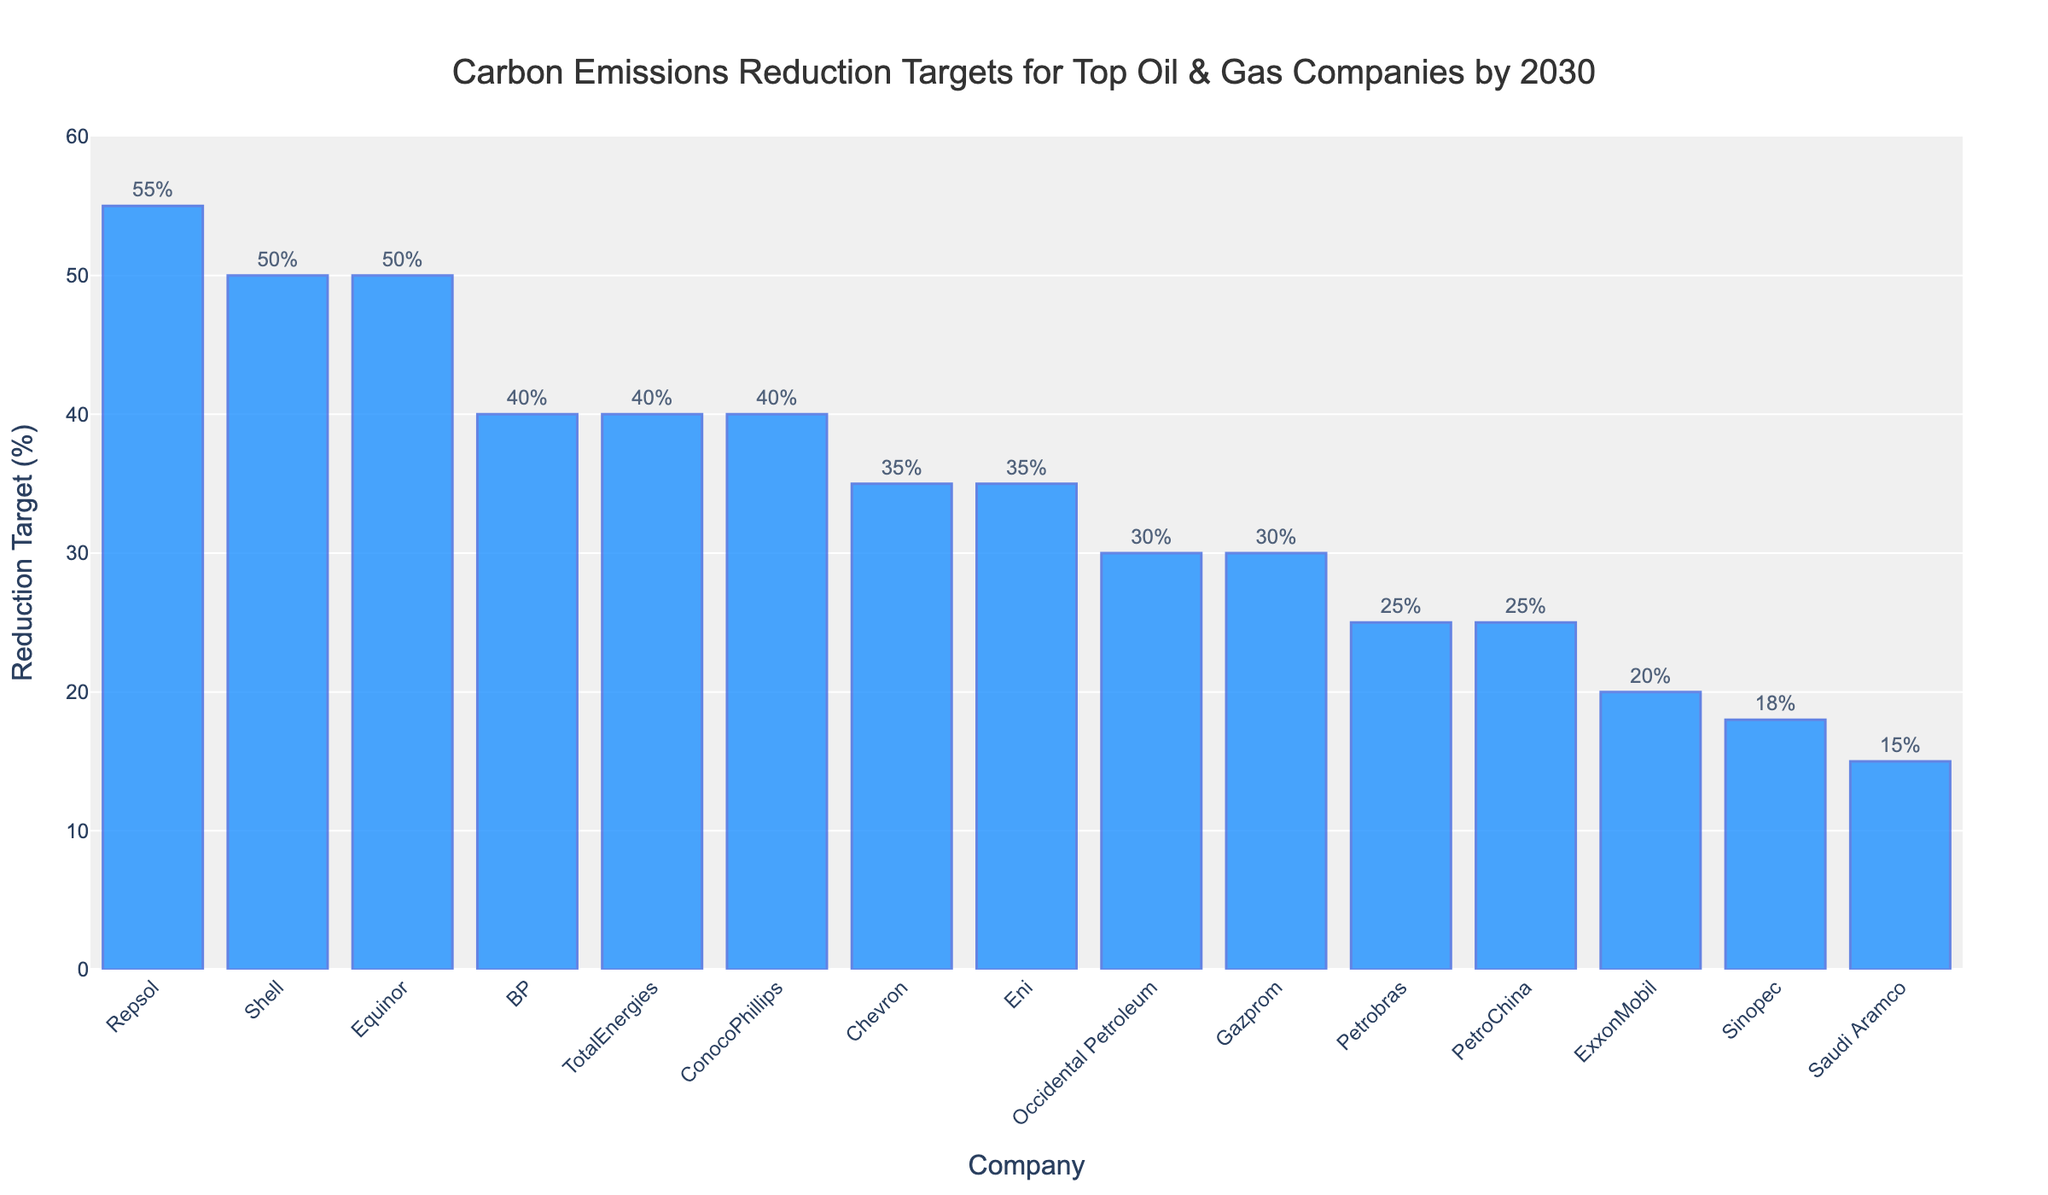Which company has the highest carbon emissions reduction target? Repsol has the highest carbon emissions reduction target of 55%. This is seen by identifying the tallest bar in the chart, which belongs to Repsol.
Answer: Repsol Which companies have a reduction target of 40% by 2030? BP, TotalEnergies, and ConocoPhillips each have a reduction target of 40% by 2030. By checking the heights of the bars and matching them to the 40% mark, these companies stand out.
Answer: BP, TotalEnergies, ConocoPhillips How does ExxonMobil compare to Chevron in terms of their reduction targets? Chevron has a higher reduction target of 35% compared to ExxonMobil's target of 20%. Comparing the heights of their respective bars shows this difference.
Answer: Chevron has a higher target What is the average reduction target value for all companies listed? To find the average, add up all the targets and divide by the number of companies: (20+35+50+40+40+40+35+50+55+30+25+15+18+25+30) / 15 = 480 / 15. The average is 32%.
Answer: 32% What is the difference between the highest and the lowest carbon emissions reduction targets? The highest target is 55% (Repsol) and the lowest is 15% (Saudi Aramco). The difference between these values is 55% - 15% = 40%.
Answer: 40% Which companies have targets greater than 45%? Shell, Equinor, and Repsol have targets greater than 45%, as their bars extend above the 45% mark.
Answer: Shell, Equinor, Repsol Among Sinopec, Petrobras, and Chevron, which company has the lowest reduction target? Sinopec has the lowest reduction target of 18% among these three companies. This is observed by comparing the heights of their respective bars.
Answer: Sinopec What is the combined reduction target of Petrobras and Shell? Petrobras has a reduction target of 25% and Shell has a target of 50%. Combined, they have a target of 25% + 50% = 75%.
Answer: 75% What is the median carbon emissions reduction target among all the companies listed? To find the median, first, order the targets: 15, 18, 20, 25, 25, 30, 30, 35, 35, 40, 40, 40, 50, 50, 55. The median is the 8th value in this list, which is 35.
Answer: 35 